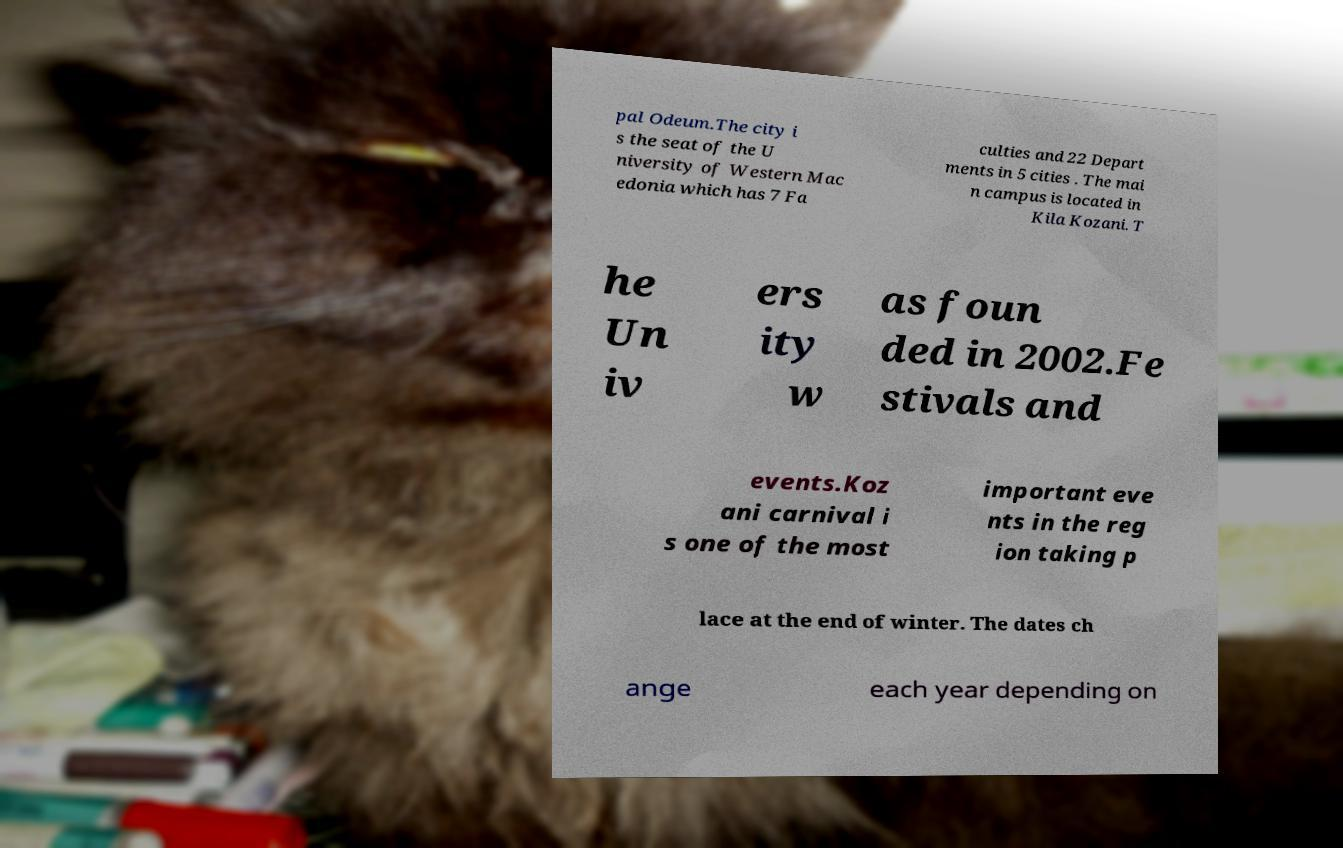Can you accurately transcribe the text from the provided image for me? pal Odeum.The city i s the seat of the U niversity of Western Mac edonia which has 7 Fa culties and 22 Depart ments in 5 cities . The mai n campus is located in Kila Kozani. T he Un iv ers ity w as foun ded in 2002.Fe stivals and events.Koz ani carnival i s one of the most important eve nts in the reg ion taking p lace at the end of winter. The dates ch ange each year depending on 